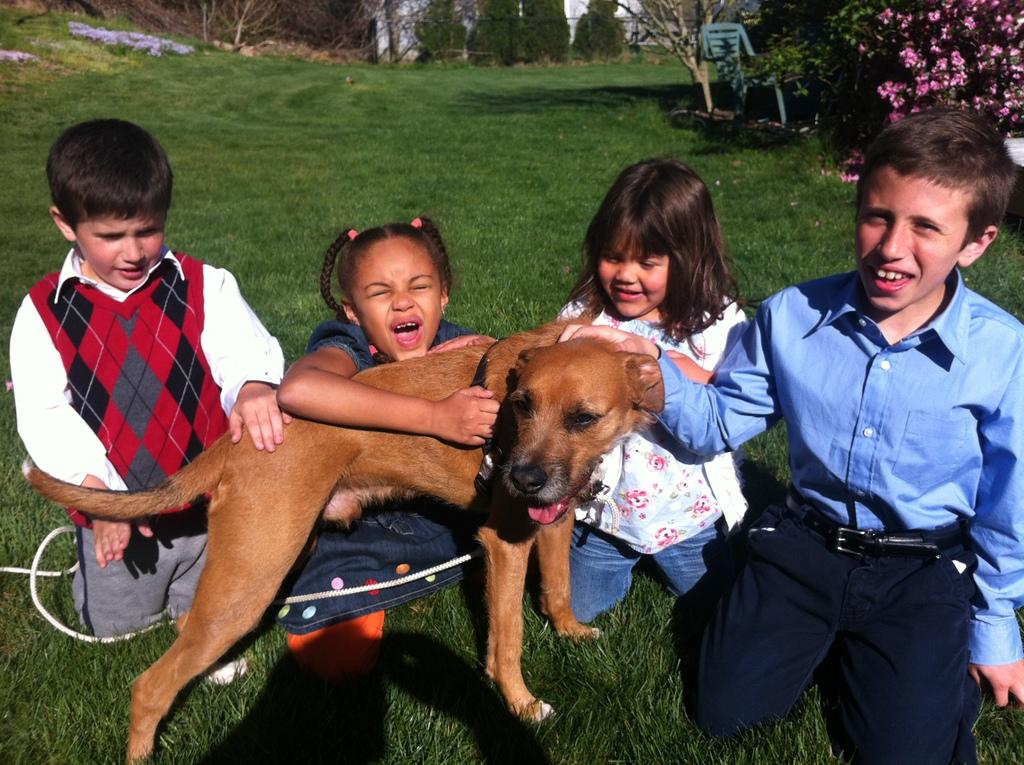How many kids are sitting on the grass in the image? There are four kids sitting on the grass in the image. What is in front of the kids? There is a dog in front of the kids. Who is holding the dog? A girl is holding the dog. What can be seen in the distance in the image? There are plants with flowers in the distance. What type of furniture is present in the image? There is a chair in the image. What color is the grass in the image? The grass is green. What type of card is being passed between the kids in the image? There is no card being passed between the kids in the image. What parcel is being delivered to the kids in the image? There is no parcel being delivered to the kids in the image. 